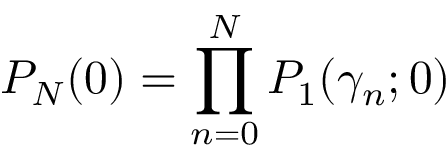Convert formula to latex. <formula><loc_0><loc_0><loc_500><loc_500>P _ { N } ( 0 ) = \prod _ { n = 0 } ^ { N } P _ { 1 } ( \gamma _ { n } ; 0 )</formula> 